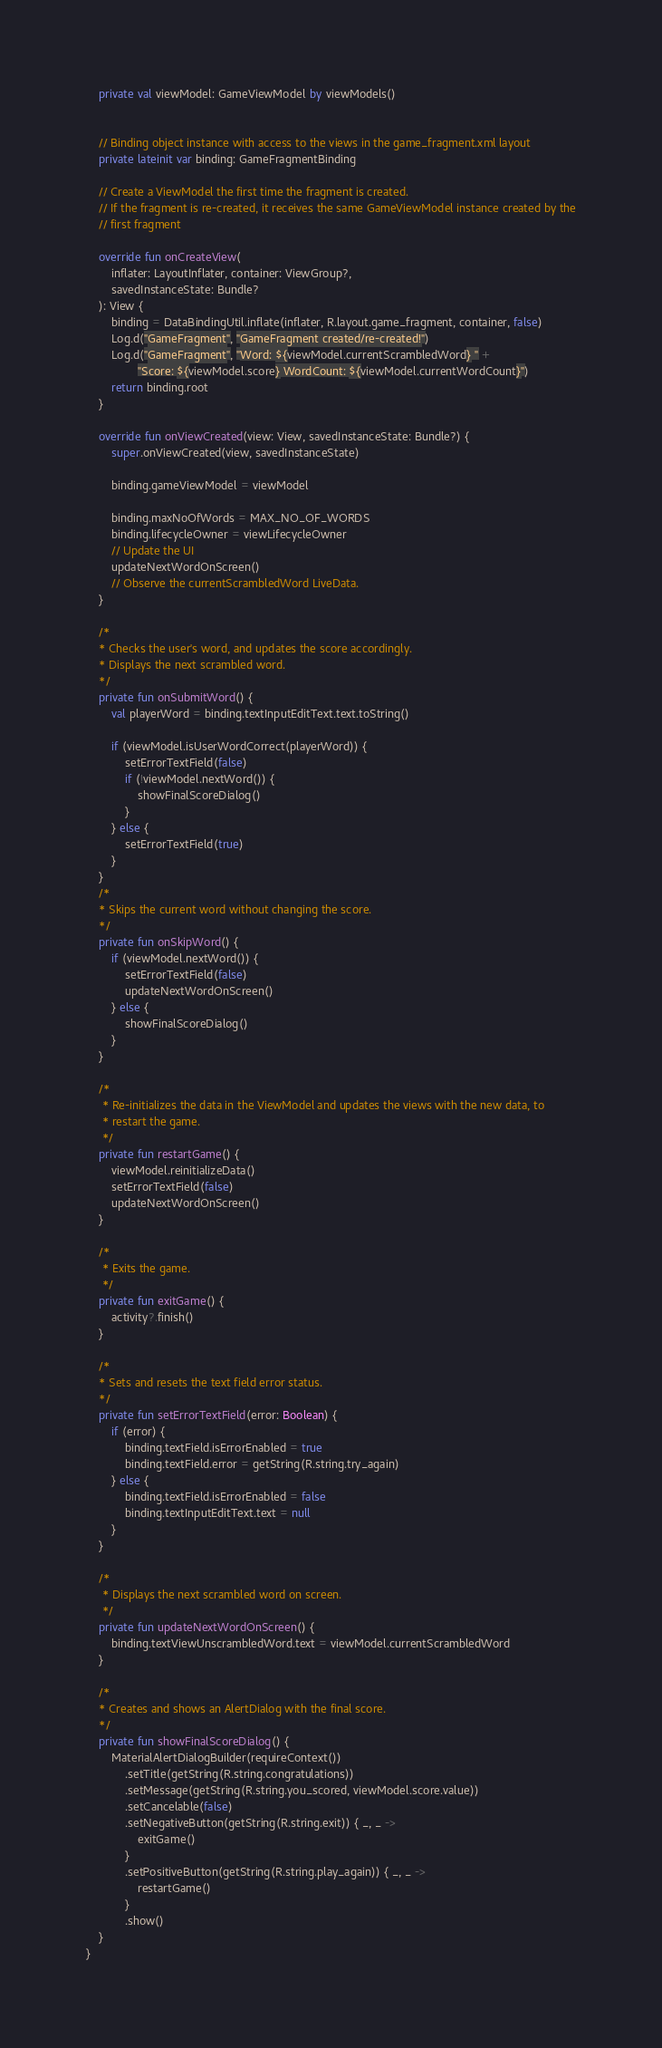<code> <loc_0><loc_0><loc_500><loc_500><_Kotlin_>    private val viewModel: GameViewModel by viewModels()


    // Binding object instance with access to the views in the game_fragment.xml layout
    private lateinit var binding: GameFragmentBinding

    // Create a ViewModel the first time the fragment is created.
    // If the fragment is re-created, it receives the same GameViewModel instance created by the
    // first fragment

    override fun onCreateView(
        inflater: LayoutInflater, container: ViewGroup?,
        savedInstanceState: Bundle?
    ): View {
        binding = DataBindingUtil.inflate(inflater, R.layout.game_fragment, container, false)
        Log.d("GameFragment", "GameFragment created/re-created!")
        Log.d("GameFragment", "Word: ${viewModel.currentScrambledWord} " +
                "Score: ${viewModel.score} WordCount: ${viewModel.currentWordCount}")
        return binding.root
    }

    override fun onViewCreated(view: View, savedInstanceState: Bundle?) {
        super.onViewCreated(view, savedInstanceState)

        binding.gameViewModel = viewModel

        binding.maxNoOfWords = MAX_NO_OF_WORDS
        binding.lifecycleOwner = viewLifecycleOwner
        // Update the UI
        updateNextWordOnScreen()
        // Observe the currentScrambledWord LiveData.
    }

    /*
    * Checks the user's word, and updates the score accordingly.
    * Displays the next scrambled word.
    */
    private fun onSubmitWord() {
        val playerWord = binding.textInputEditText.text.toString()

        if (viewModel.isUserWordCorrect(playerWord)) {
            setErrorTextField(false)
            if (!viewModel.nextWord()) {
                showFinalScoreDialog()
            }
        } else {
            setErrorTextField(true)
        }
    }
    /*
    * Skips the current word without changing the score.
    */
    private fun onSkipWord() {
        if (viewModel.nextWord()) {
            setErrorTextField(false)
            updateNextWordOnScreen()
        } else {
            showFinalScoreDialog()
        }
    }

    /*
     * Re-initializes the data in the ViewModel and updates the views with the new data, to
     * restart the game.
     */
    private fun restartGame() {
        viewModel.reinitializeData()
        setErrorTextField(false)
        updateNextWordOnScreen()
    }

    /*
     * Exits the game.
     */
    private fun exitGame() {
        activity?.finish()
    }

    /*
    * Sets and resets the text field error status.
    */
    private fun setErrorTextField(error: Boolean) {
        if (error) {
            binding.textField.isErrorEnabled = true
            binding.textField.error = getString(R.string.try_again)
        } else {
            binding.textField.isErrorEnabled = false
            binding.textInputEditText.text = null
        }
    }

    /*
     * Displays the next scrambled word on screen.
     */
    private fun updateNextWordOnScreen() {
        binding.textViewUnscrambledWord.text = viewModel.currentScrambledWord
    }

    /*
    * Creates and shows an AlertDialog with the final score.
    */
    private fun showFinalScoreDialog() {
        MaterialAlertDialogBuilder(requireContext())
            .setTitle(getString(R.string.congratulations))
            .setMessage(getString(R.string.you_scored, viewModel.score.value))
            .setCancelable(false)
            .setNegativeButton(getString(R.string.exit)) { _, _ ->
                exitGame()
            }
            .setPositiveButton(getString(R.string.play_again)) { _, _ ->
                restartGame()
            }
            .show()
    }
}
</code> 